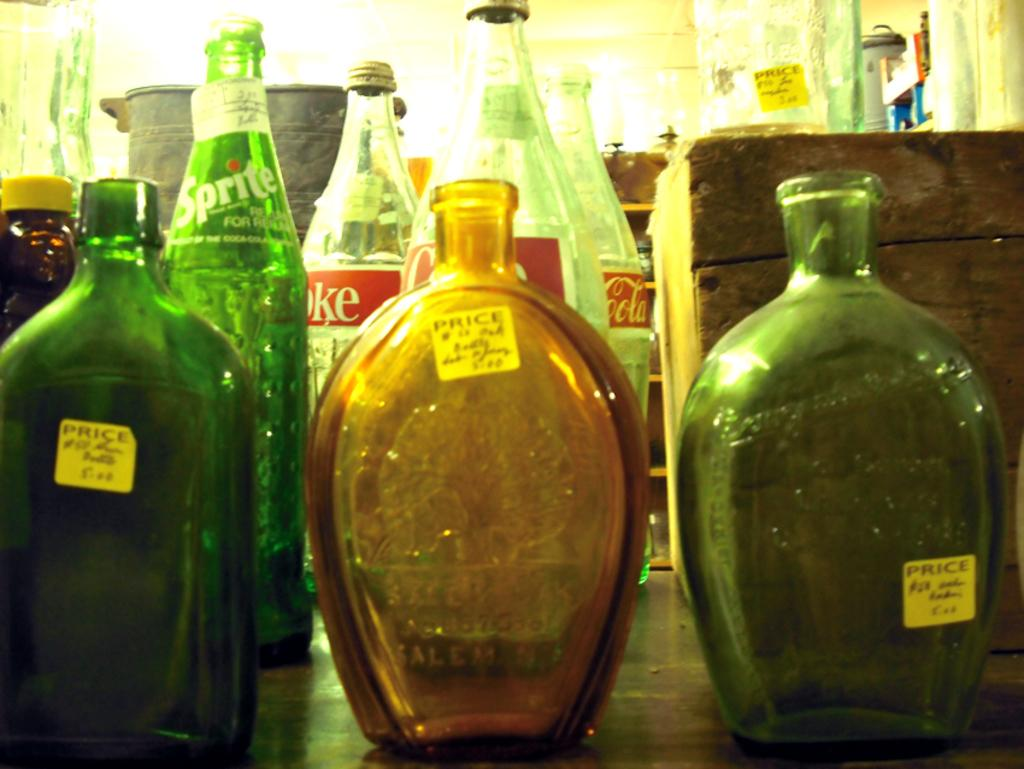What objects are present in the image? There are bottles in the image. What type of underwear can be seen on the band in the image? There is no band or underwear present in the image; only bottles are visible. 